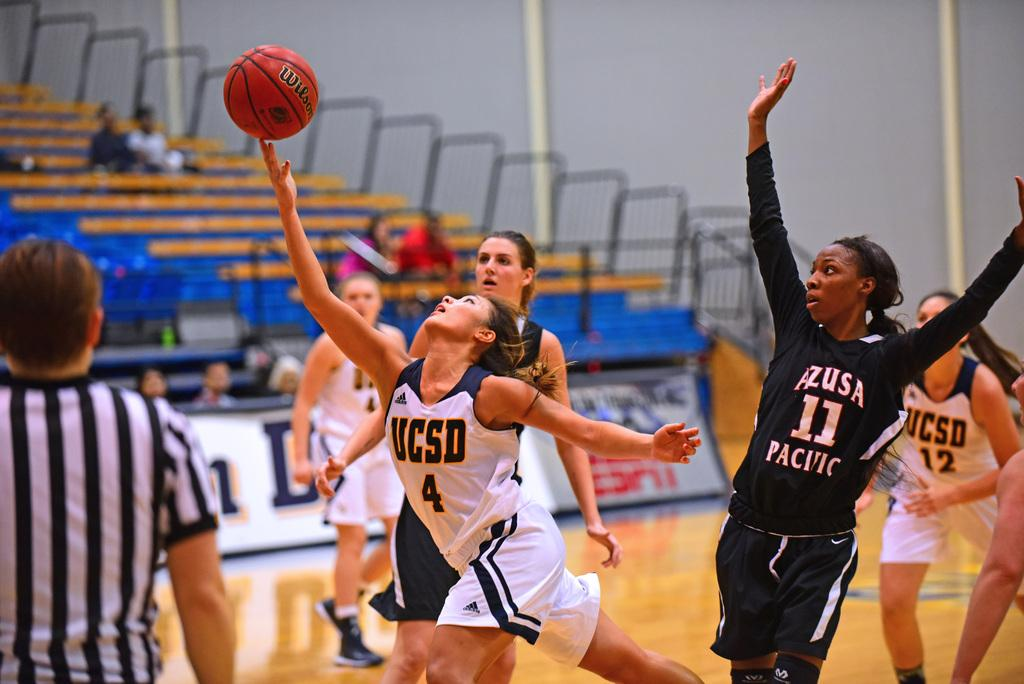<image>
Describe the image concisely. A female basketball player from UCSD holds a Wilson ball in a basketball game. 